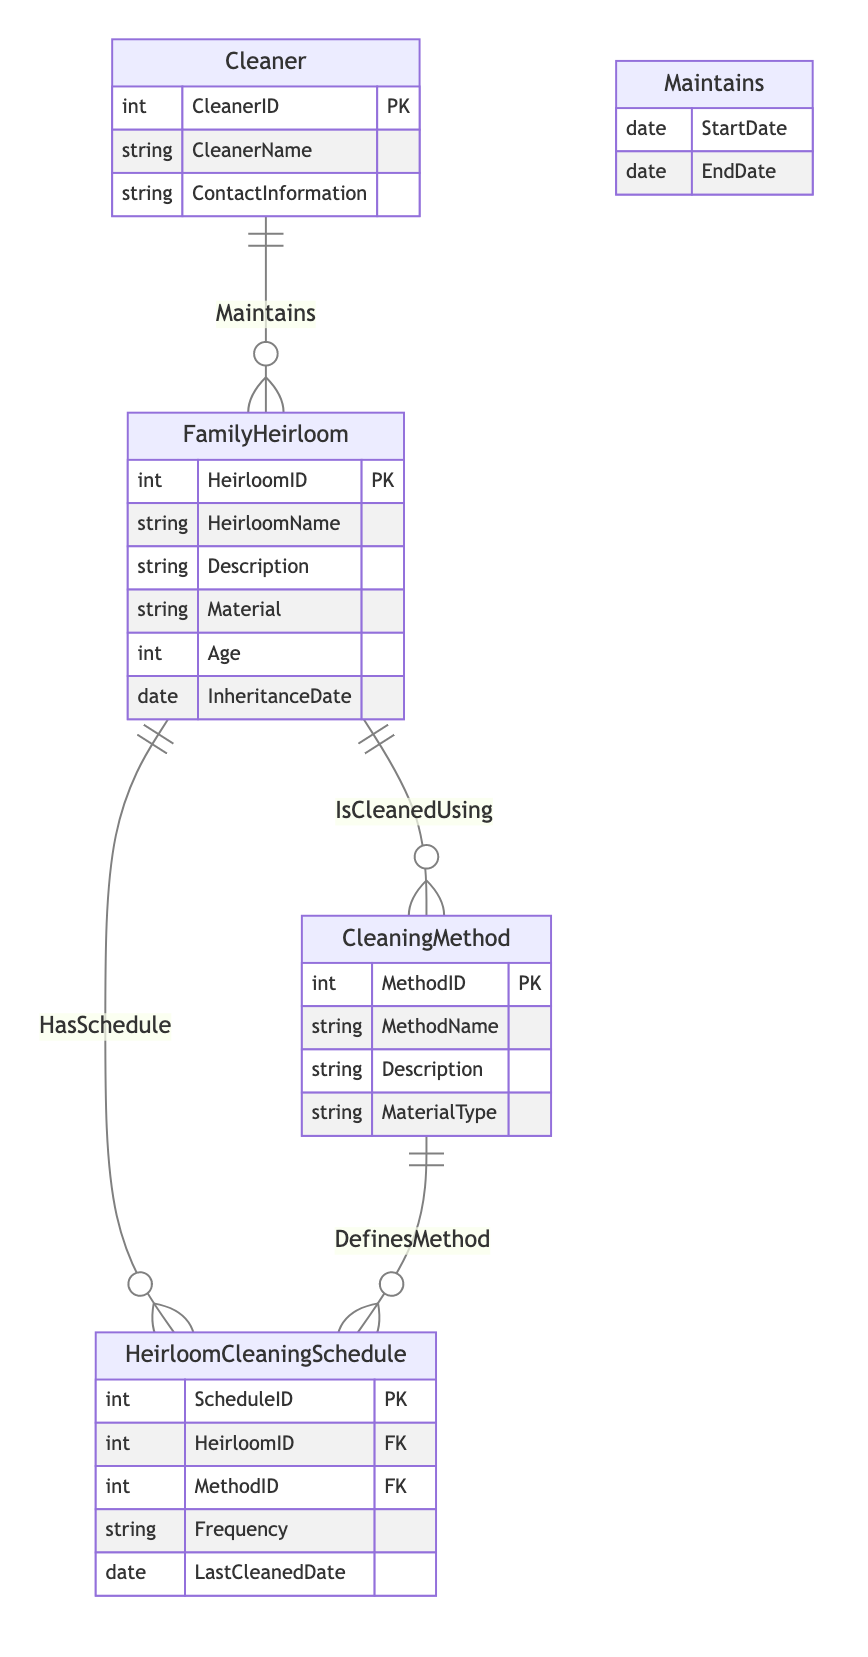What is the primary key of the Family Heirloom entity? The Family Heirloom entity has the HeirloomID as its primary key, as indicated by the "PK" notation next to it in the diagram.
Answer: HeirloomID How many attributes does the Cleaning Method entity have? The Cleaning Method entity has four attributes listed: MethodID, MethodName, Description, and MaterialType, which can be counted directly from the diagram.
Answer: Four What is the relationship between Cleaner and Family Heirloom? The relationship between Cleaner and Family Heirloom is labeled as "Maintains." This indicates how cleaners are associated with the maintenance of heirlooms.
Answer: Maintains What is the frequency of cleaning for a given heirloom? The frequency of cleaning for a given heirloom is found in the Heirloom Cleaning Schedule entity under the attribute called Frequency, which signifies how often cleaning should occur.
Answer: Frequency Which entity defines the cleaning method used for heirlooms? The cleaning methods used for heirlooms are defined by the Cleaning Method entity through the relationship labeled "DefinesMethod" in the diagram, which connects Cleaning Method and Heirloom Cleaning Schedule.
Answer: Cleaning Method How many entities are present in the diagram? The diagram contains four entities: Family Heirloom, Cleaning Method, Heirloom Cleaning Schedule, and Cleaner. The count can be determined by reviewing the entities section in the diagram.
Answer: Four What attributes are associated with the relationship that involves Cleaner and Family Heirloom? The relationship "Maintains" between Cleaner and Family Heirloom includes the attributes StartDate and EndDate which provide time frames for when a cleaner maintains the heirloom.
Answer: StartDate, EndDate What does the HeirloomCleaningSchedule entity contain regarding the last cleaning date? The Heirloom Cleaning Schedule entity includes the attribute LastCleanedDate, which records the date of the most recent cleaning of a specific heirloom.
Answer: LastCleanedDate Which two entities are connected by "IsCleanedUsing"? The "IsCleanedUsing" relationship connects the Family Heirloom entity with the Cleaning Method entity, indicating which cleaning methods are used for specific heirlooms.
Answer: Family Heirloom, Cleaning Method 